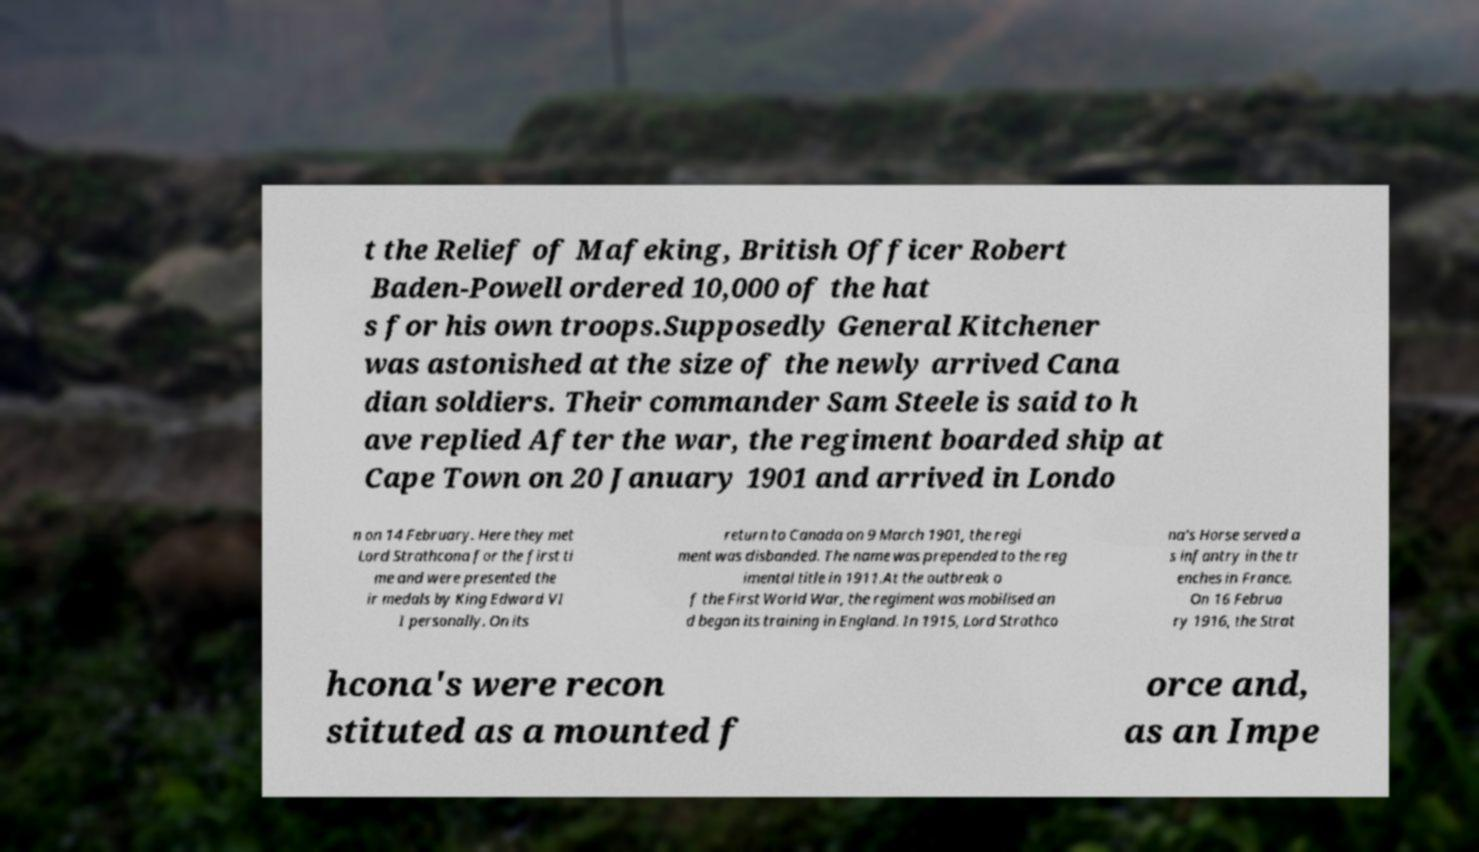There's text embedded in this image that I need extracted. Can you transcribe it verbatim? t the Relief of Mafeking, British Officer Robert Baden-Powell ordered 10,000 of the hat s for his own troops.Supposedly General Kitchener was astonished at the size of the newly arrived Cana dian soldiers. Their commander Sam Steele is said to h ave replied After the war, the regiment boarded ship at Cape Town on 20 January 1901 and arrived in Londo n on 14 February. Here they met Lord Strathcona for the first ti me and were presented the ir medals by King Edward VI I personally. On its return to Canada on 9 March 1901, the regi ment was disbanded. The name was prepended to the reg imental title in 1911.At the outbreak o f the First World War, the regiment was mobilised an d began its training in England. In 1915, Lord Strathco na's Horse served a s infantry in the tr enches in France. On 16 Februa ry 1916, the Strat hcona's were recon stituted as a mounted f orce and, as an Impe 